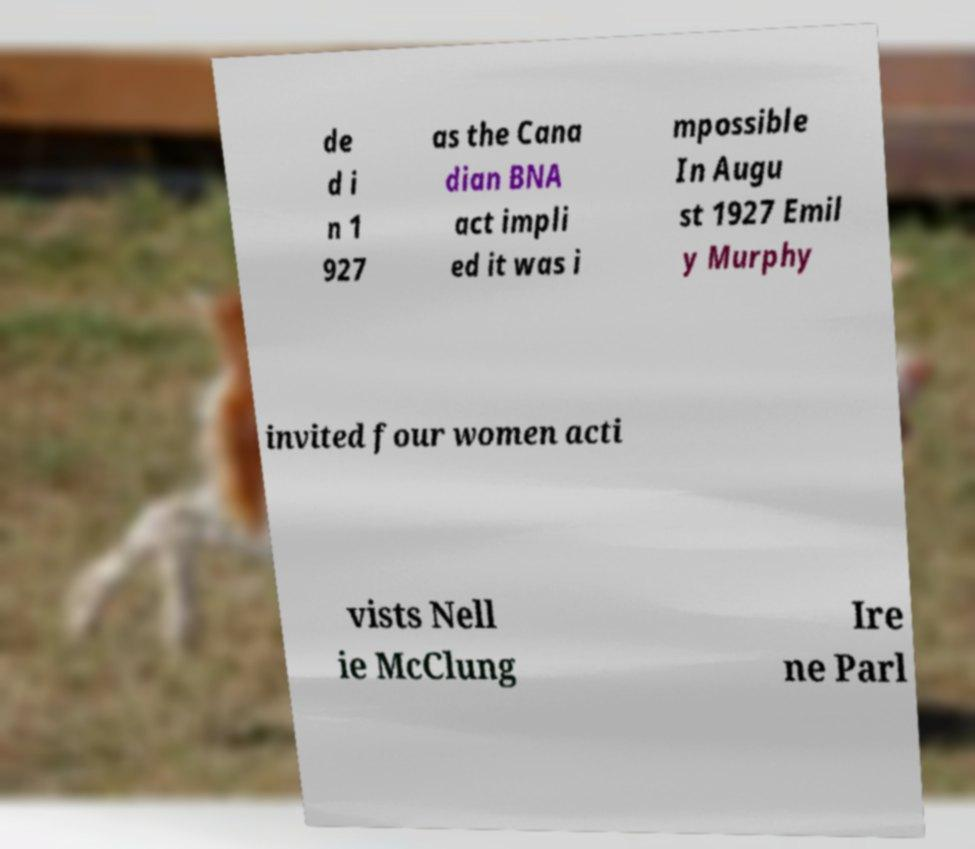Can you accurately transcribe the text from the provided image for me? de d i n 1 927 as the Cana dian BNA act impli ed it was i mpossible In Augu st 1927 Emil y Murphy invited four women acti vists Nell ie McClung Ire ne Parl 